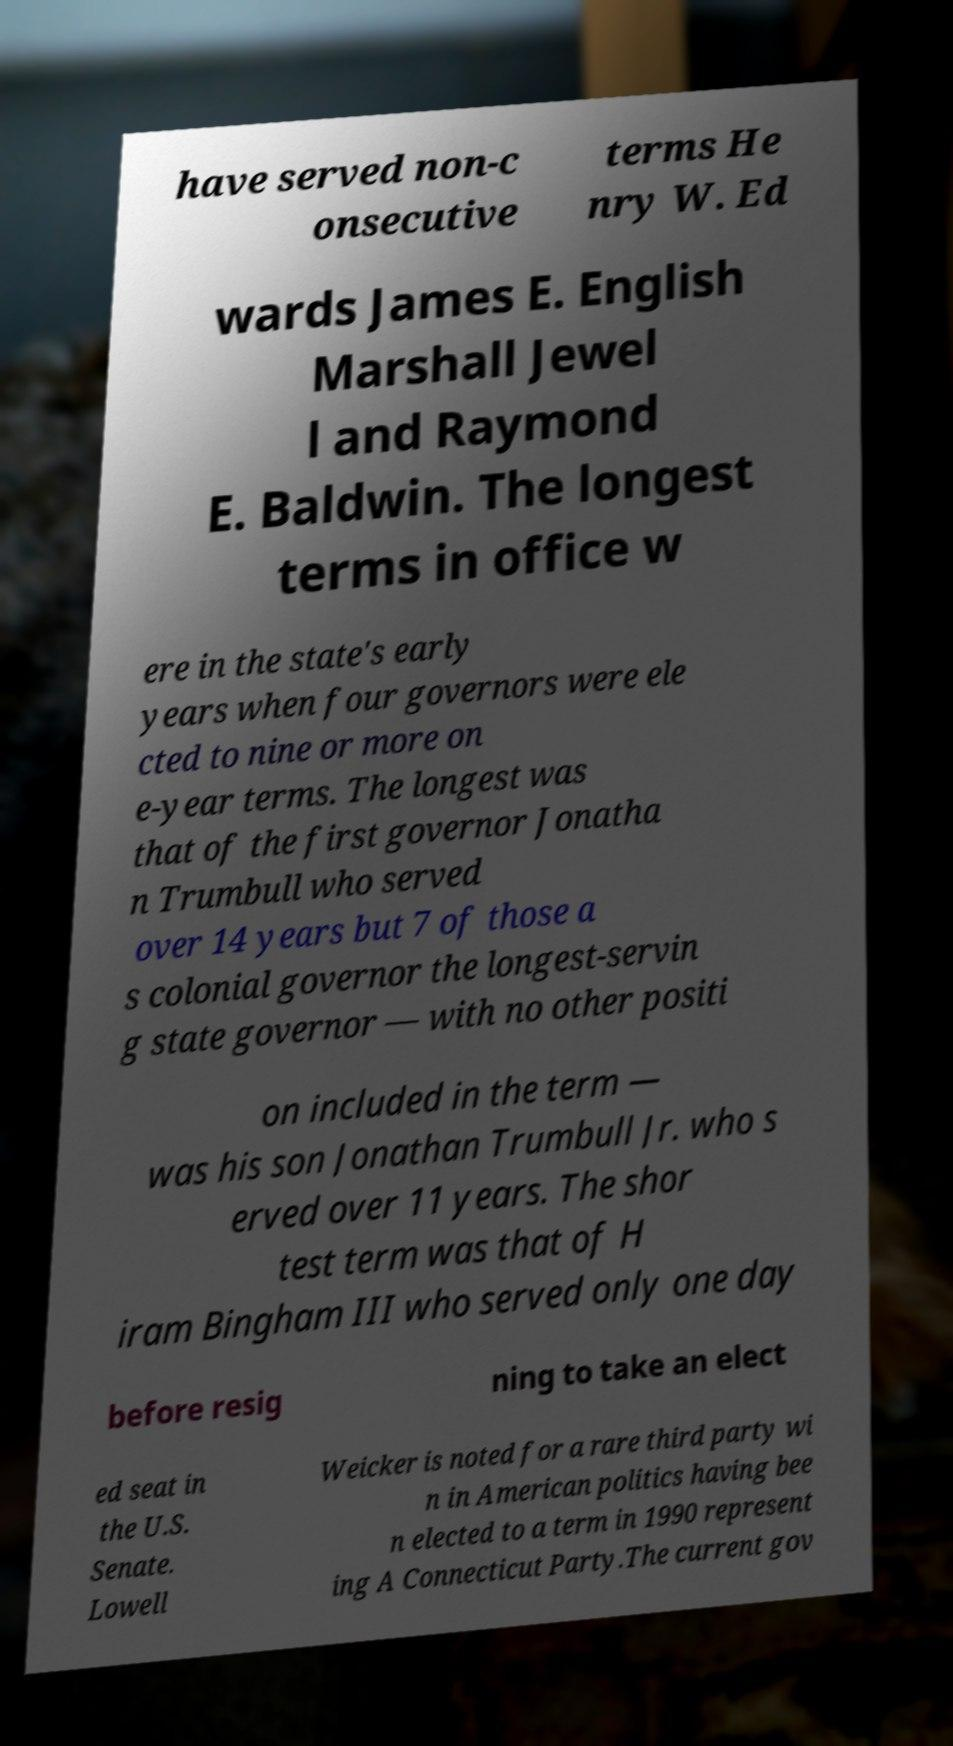For documentation purposes, I need the text within this image transcribed. Could you provide that? have served non-c onsecutive terms He nry W. Ed wards James E. English Marshall Jewel l and Raymond E. Baldwin. The longest terms in office w ere in the state's early years when four governors were ele cted to nine or more on e-year terms. The longest was that of the first governor Jonatha n Trumbull who served over 14 years but 7 of those a s colonial governor the longest-servin g state governor — with no other positi on included in the term — was his son Jonathan Trumbull Jr. who s erved over 11 years. The shor test term was that of H iram Bingham III who served only one day before resig ning to take an elect ed seat in the U.S. Senate. Lowell Weicker is noted for a rare third party wi n in American politics having bee n elected to a term in 1990 represent ing A Connecticut Party.The current gov 